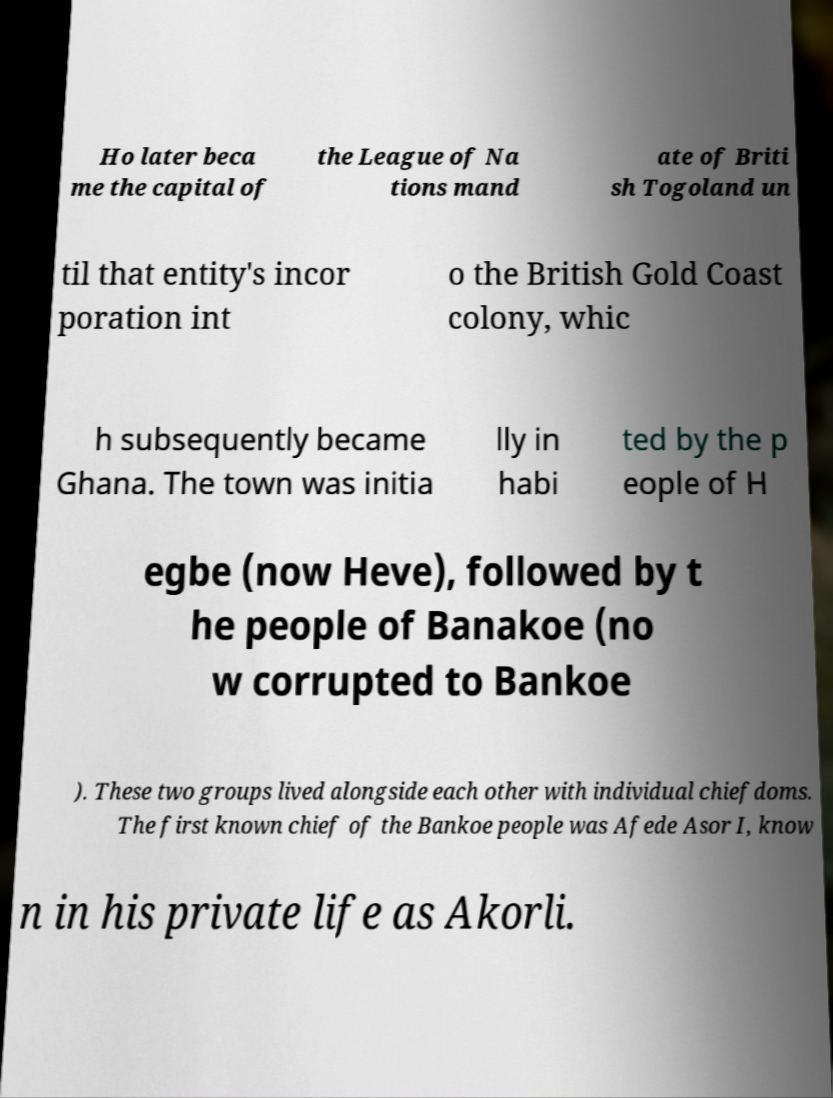Can you accurately transcribe the text from the provided image for me? Ho later beca me the capital of the League of Na tions mand ate of Briti sh Togoland un til that entity's incor poration int o the British Gold Coast colony, whic h subsequently became Ghana. The town was initia lly in habi ted by the p eople of H egbe (now Heve), followed by t he people of Banakoe (no w corrupted to Bankoe ). These two groups lived alongside each other with individual chiefdoms. The first known chief of the Bankoe people was Afede Asor I, know n in his private life as Akorli. 